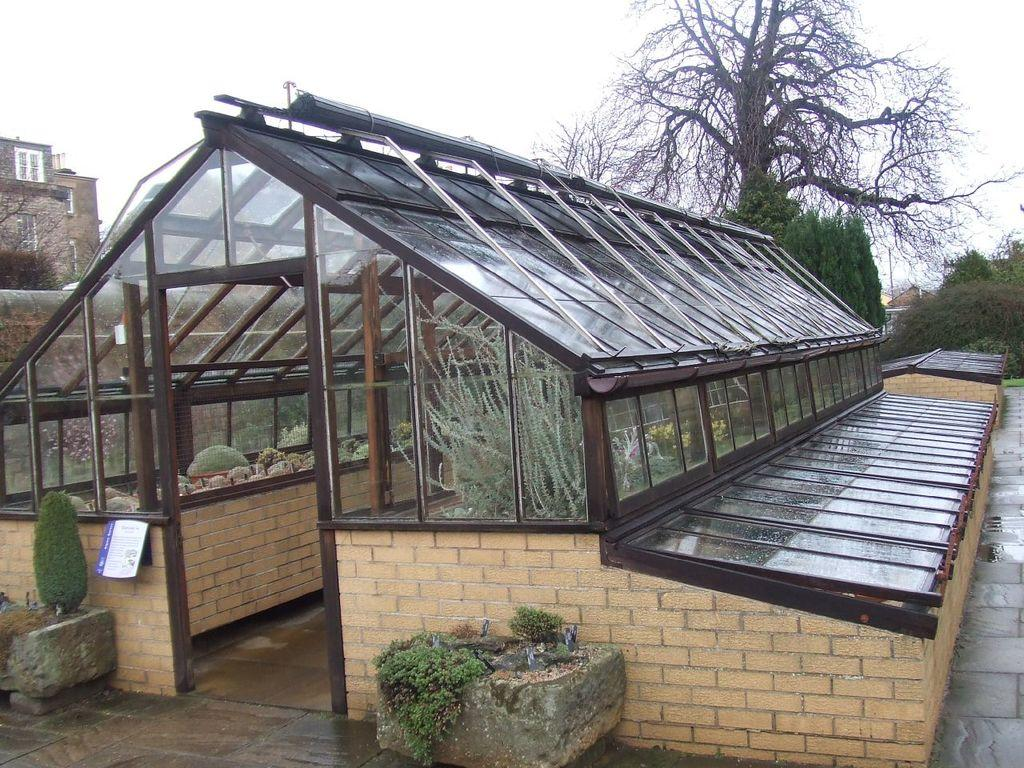What type of structure can be seen in the image? There is a shed in the image. What other objects or features are present in the image? There are house plants, trees, a building, and the sky visible in the image. Can you describe the vegetation in the image? There are house plants and trees present in the image. What is the time of day when the image was likely taken? The image was likely taken during the day, as the sky is visible. What type of neck accessory is being worn by the stone in the image? There is no stone or neck accessory present in the image. 